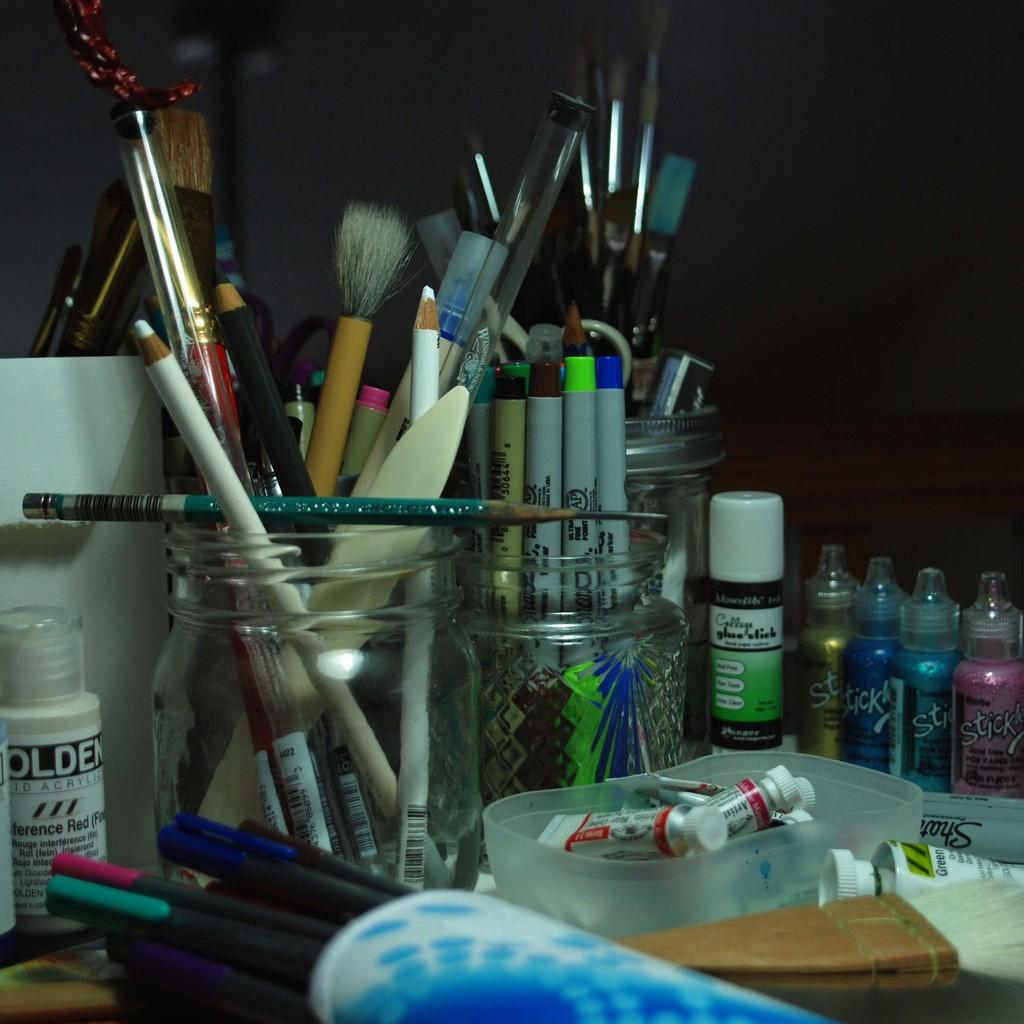<image>
Write a terse but informative summary of the picture. Various art supplies are on a table or in glass jars, including a Collage glue stick. 